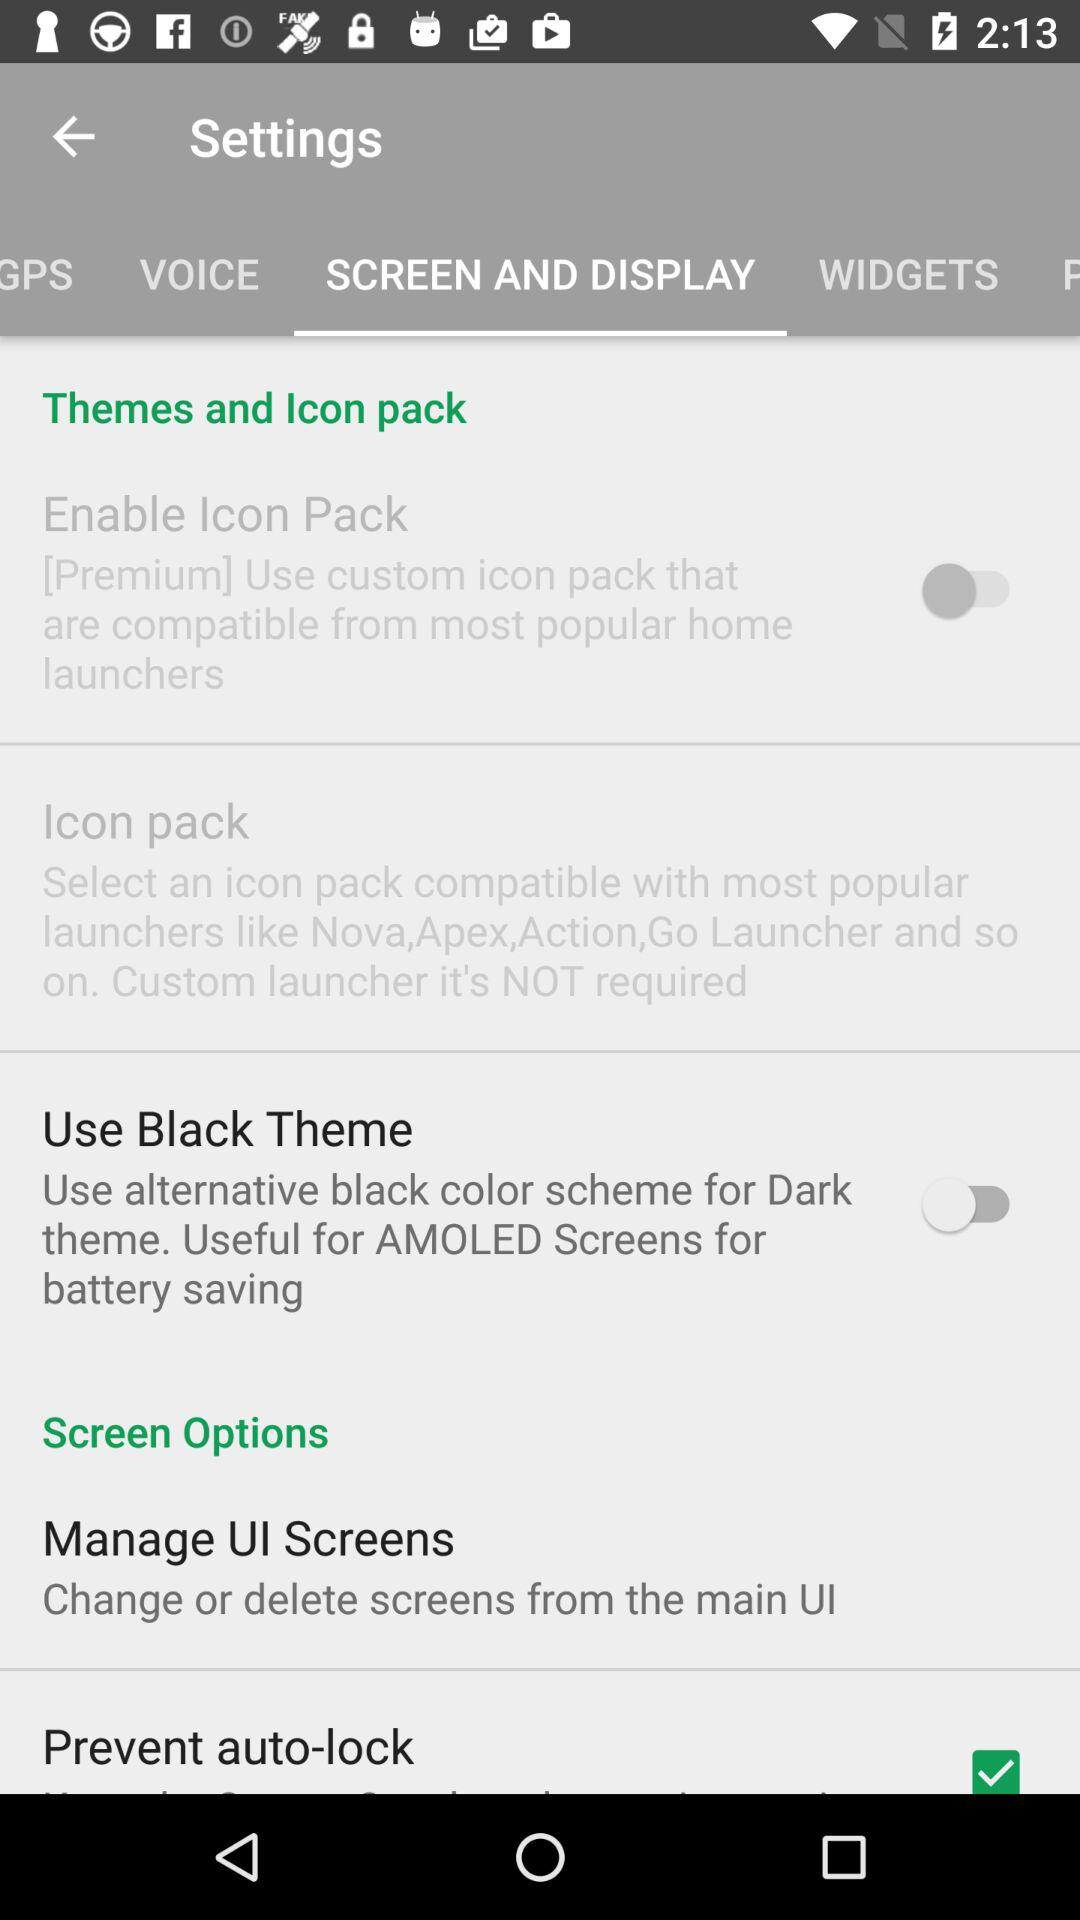Which tab is open? The open tab is "SCREEN AND DISPLAY". 